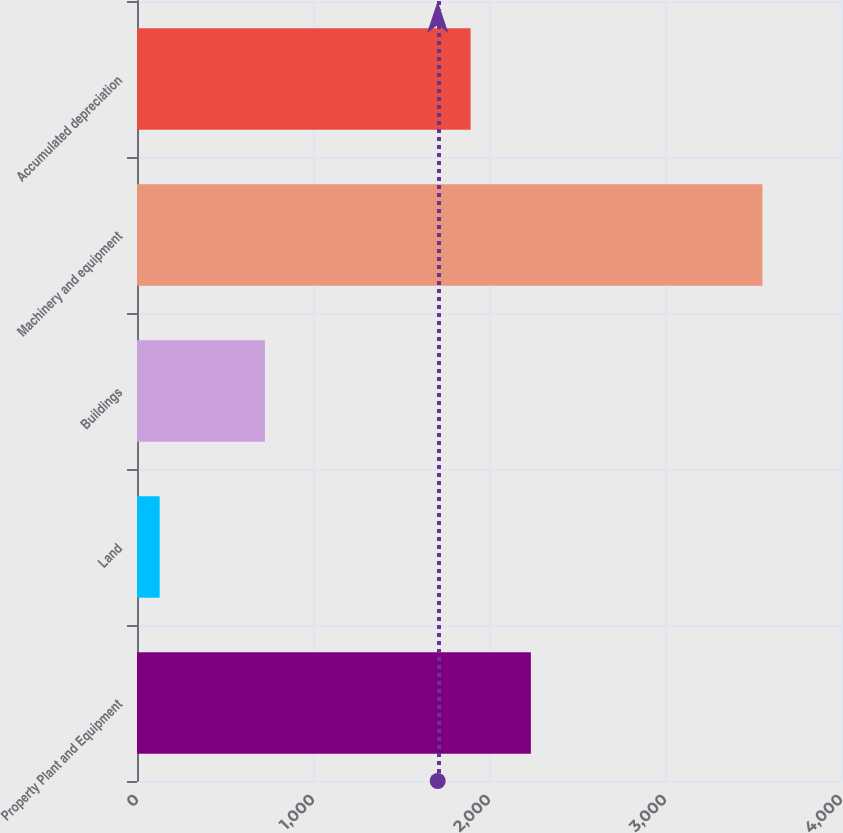Convert chart to OTSL. <chart><loc_0><loc_0><loc_500><loc_500><bar_chart><fcel>Property Plant and Equipment<fcel>Land<fcel>Buildings<fcel>Machinery and equipment<fcel>Accumulated depreciation<nl><fcel>2237.86<fcel>128.8<fcel>726.7<fcel>3553.4<fcel>1895.4<nl></chart> 